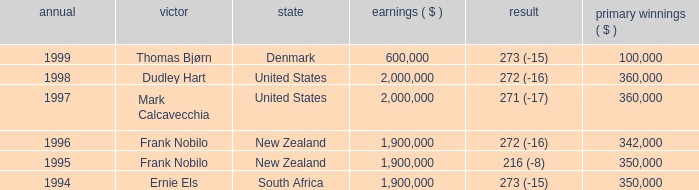What was the total purse in the years after 1996 with a score of 272 (-16) when frank nobilo won? None. 